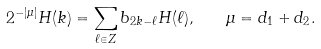Convert formula to latex. <formula><loc_0><loc_0><loc_500><loc_500>2 ^ { - | \mu | } H ( k ) = \sum _ { \ell \in { Z } } b _ { 2 k - \ell } H ( \ell ) , \quad \mu = d _ { 1 } + d _ { 2 } .</formula> 